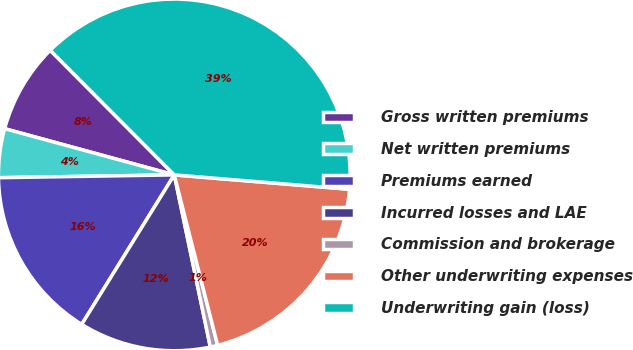Convert chart. <chart><loc_0><loc_0><loc_500><loc_500><pie_chart><fcel>Gross written premiums<fcel>Net written premiums<fcel>Premiums earned<fcel>Incurred losses and LAE<fcel>Commission and brokerage<fcel>Other underwriting expenses<fcel>Underwriting gain (loss)<nl><fcel>8.3%<fcel>4.49%<fcel>15.92%<fcel>12.11%<fcel>0.68%<fcel>19.73%<fcel>38.77%<nl></chart> 